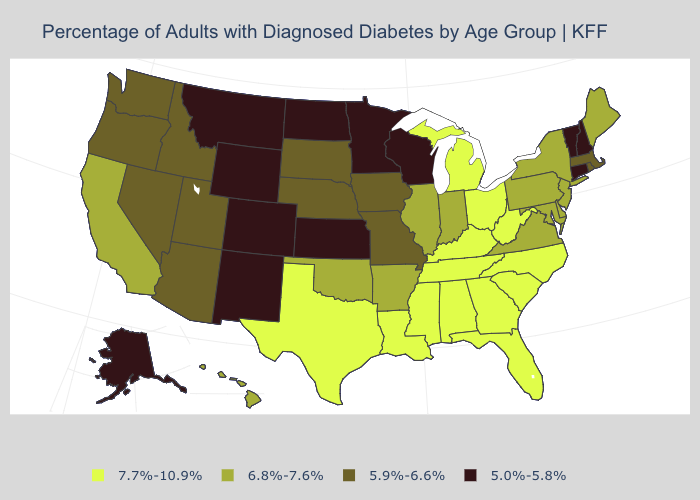What is the value of Wyoming?
Concise answer only. 5.0%-5.8%. Name the states that have a value in the range 5.0%-5.8%?
Keep it brief. Alaska, Colorado, Connecticut, Kansas, Minnesota, Montana, New Hampshire, New Mexico, North Dakota, Vermont, Wisconsin, Wyoming. What is the lowest value in states that border Texas?
Keep it brief. 5.0%-5.8%. What is the highest value in the MidWest ?
Concise answer only. 7.7%-10.9%. Among the states that border Maine , which have the lowest value?
Keep it brief. New Hampshire. What is the value of Iowa?
Keep it brief. 5.9%-6.6%. Which states have the lowest value in the MidWest?
Short answer required. Kansas, Minnesota, North Dakota, Wisconsin. Is the legend a continuous bar?
Give a very brief answer. No. What is the value of New Mexico?
Short answer required. 5.0%-5.8%. What is the value of Maryland?
Keep it brief. 6.8%-7.6%. Name the states that have a value in the range 7.7%-10.9%?
Answer briefly. Alabama, Florida, Georgia, Kentucky, Louisiana, Michigan, Mississippi, North Carolina, Ohio, South Carolina, Tennessee, Texas, West Virginia. Name the states that have a value in the range 6.8%-7.6%?
Quick response, please. Arkansas, California, Delaware, Hawaii, Illinois, Indiana, Maine, Maryland, New Jersey, New York, Oklahoma, Pennsylvania, Virginia. How many symbols are there in the legend?
Give a very brief answer. 4. Which states have the highest value in the USA?
Answer briefly. Alabama, Florida, Georgia, Kentucky, Louisiana, Michigan, Mississippi, North Carolina, Ohio, South Carolina, Tennessee, Texas, West Virginia. Does Michigan have a higher value than Louisiana?
Give a very brief answer. No. 